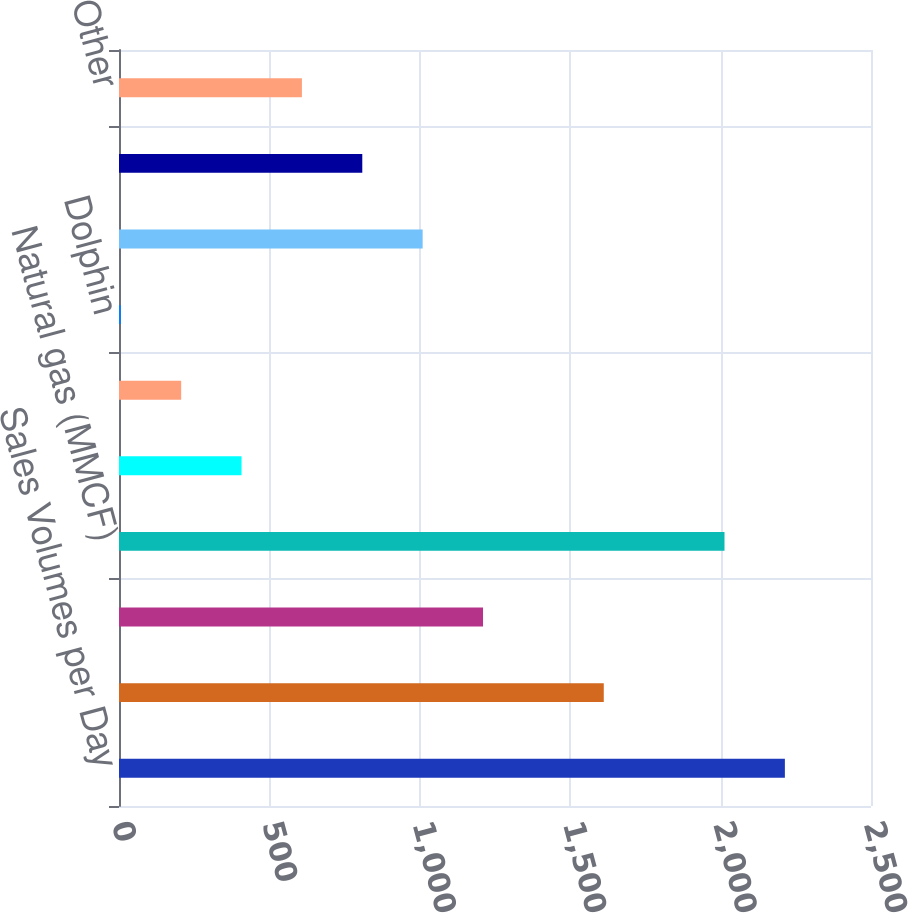Convert chart. <chart><loc_0><loc_0><loc_500><loc_500><bar_chart><fcel>Sales Volumes per Day<fcel>Oil (MBBL)<fcel>NGLs (MBBL)<fcel>Natural gas (MMCF)<fcel>Oil (MBBL) - Colombia<fcel>Natural gas (MMCF) - Bolivia<fcel>Dolphin<fcel>Oman<fcel>Qatar<fcel>Other<nl><fcel>2213.7<fcel>1611.6<fcel>1210.2<fcel>2013<fcel>407.4<fcel>206.7<fcel>6<fcel>1009.5<fcel>808.8<fcel>608.1<nl></chart> 